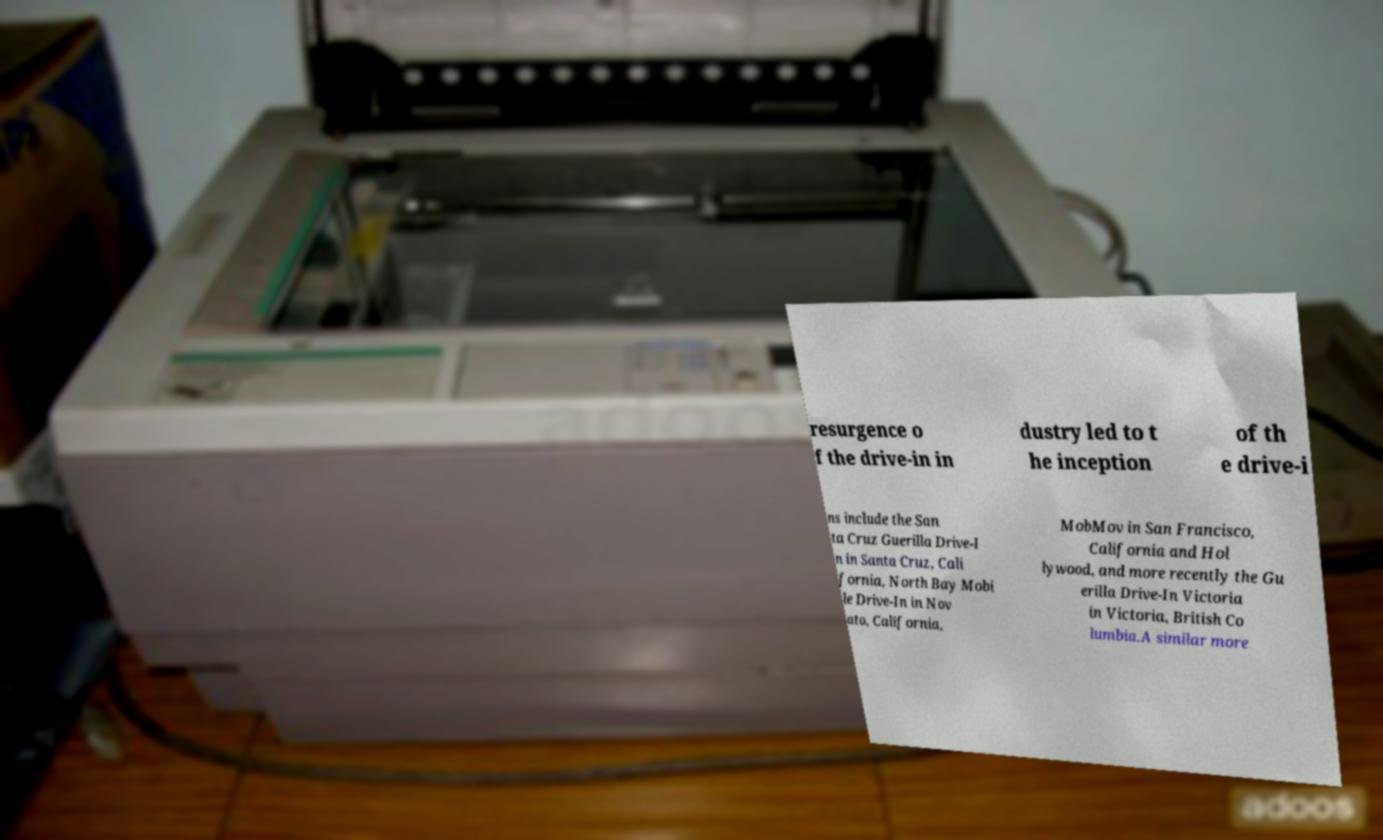Can you accurately transcribe the text from the provided image for me? resurgence o f the drive-in in dustry led to t he inception of th e drive-i ns include the San ta Cruz Guerilla Drive-I n in Santa Cruz, Cali fornia, North Bay Mobi le Drive-In in Nov ato, California, MobMov in San Francisco, California and Hol lywood, and more recently the Gu erilla Drive-In Victoria in Victoria, British Co lumbia.A similar more 